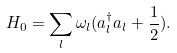<formula> <loc_0><loc_0><loc_500><loc_500>H _ { 0 } = \sum _ { l } \omega _ { l } ( a _ { l } ^ { \dagger } a _ { l } + \frac { 1 } { 2 } ) .</formula> 